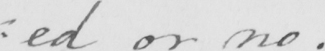What is written in this line of handwriting? : ed or no . 